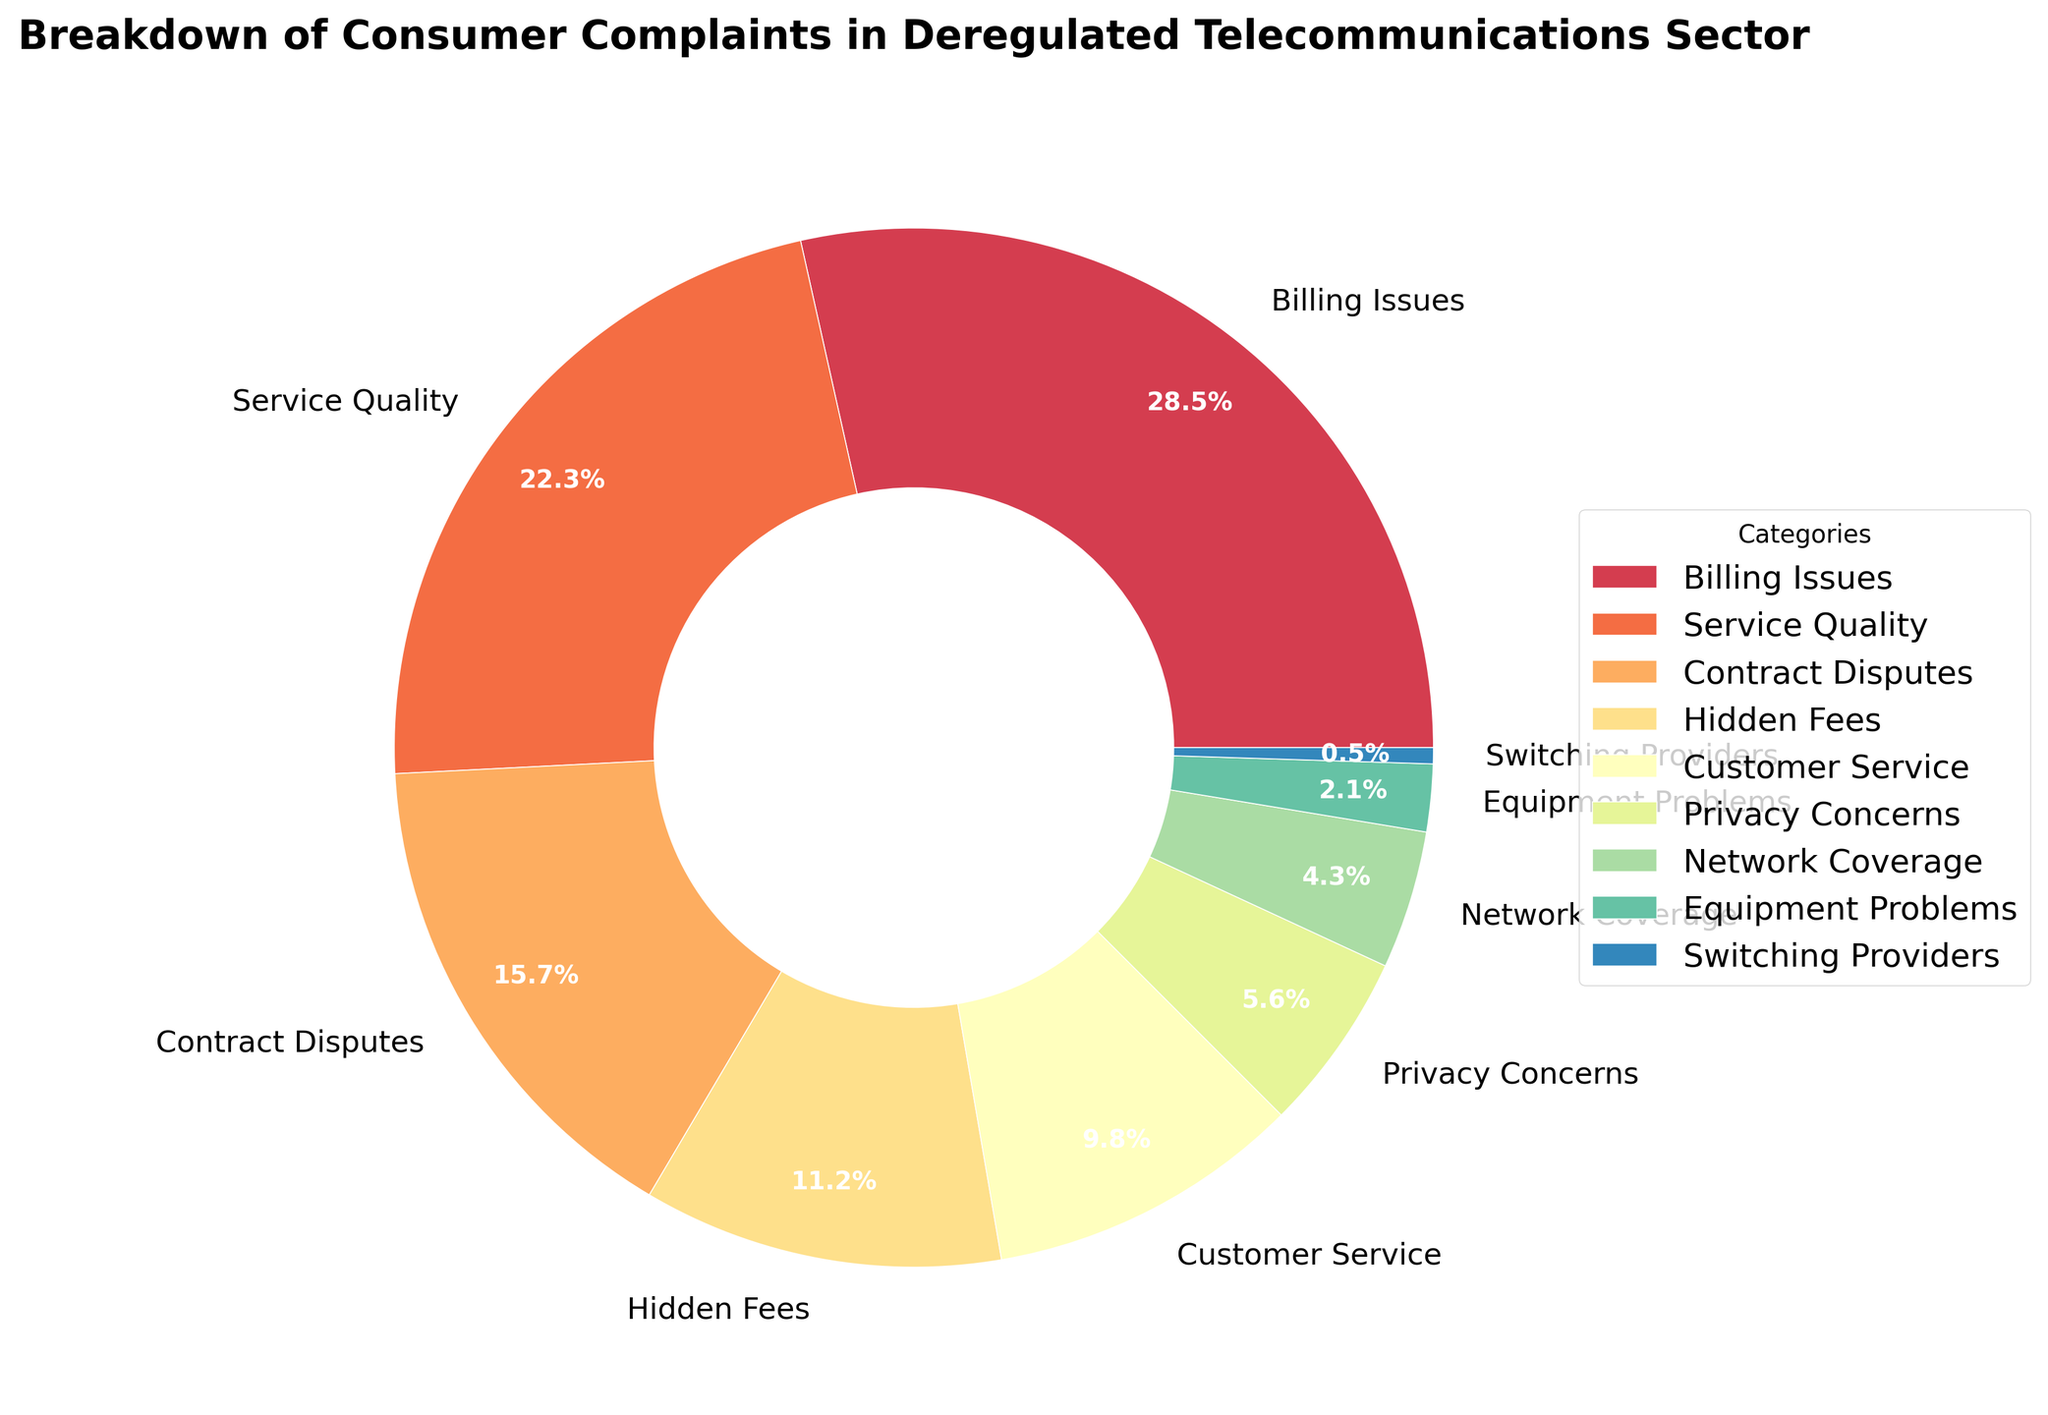What category has the highest percentage of consumer complaints? The pie chart shows different categories with their respective percentages. The largest segment represents Billing Issues with 28.5%.
Answer: Billing Issues What is the combined percentage of complaints for Contract Disputes and Hidden Fees? Contract Disputes account for 15.7% and Hidden Fees for 11.2%. Adding these gives 15.7 + 11.2 = 26.9%.
Answer: 26.9% Which category has the smallest percentage of consumer complaints? The smallest segment in the pie chart represents Switching Providers with 0.5%.
Answer: Switching Providers How many categories have a percentage of complaints higher than 10%? The categories with more than 10% are Billing Issues (28.5%), Service Quality (22.3%), Contract Disputes (15.7%), and Hidden Fees (11.2%). This totals to 4 categories.
Answer: 4 What is the difference in percentage between Service Quality and Privacy Concerns? Service Quality has 22.3% and Privacy Concerns have 5.6%. The difference is 22.3 - 5.6 = 16.7%.
Answer: 16.7% If Billing Issues and Service Quality complaints were combined into one category, what would their combined percentage be? Billing Issues are 28.5% and Service Quality is 22.3%. Summing these gives 28.5 + 22.3 = 50.8%.
Answer: 50.8% Among equipment-related issues, which has a higher percentage: Equipment Problems or Network Coverage? Network Coverage has 4.3% and Equipment Problems has 2.1%. Hence, Network Coverage is higher.
Answer: Network Coverage What portion of the pie chart is taken up by Customer Service, Hidden Fees, and Privacy Concerns together? Customer Service has 9.8%, Hidden Fees 11.2%, and Privacy Concerns 5.6%. Adding these gives 9.8 + 11.2 + 5.6 = 26.6%.
Answer: 26.6% Compare the sum of percentages for Network Coverage and Equipment Problems with the percentage for Customer Service. Which is greater? Network Coverage and Equipment Problems sum to 4.3% + 2.1% = 6.4%. Customer Service alone is 9.8%. Therefore, Customer Service is greater.
Answer: Customer Service Which category's wedge appears to be visually the largest in the pie chart? Visually, the wedge for Billing Issues occupies the largest space in the pie chart, corresponding to 28.5%.
Answer: Billing Issues 